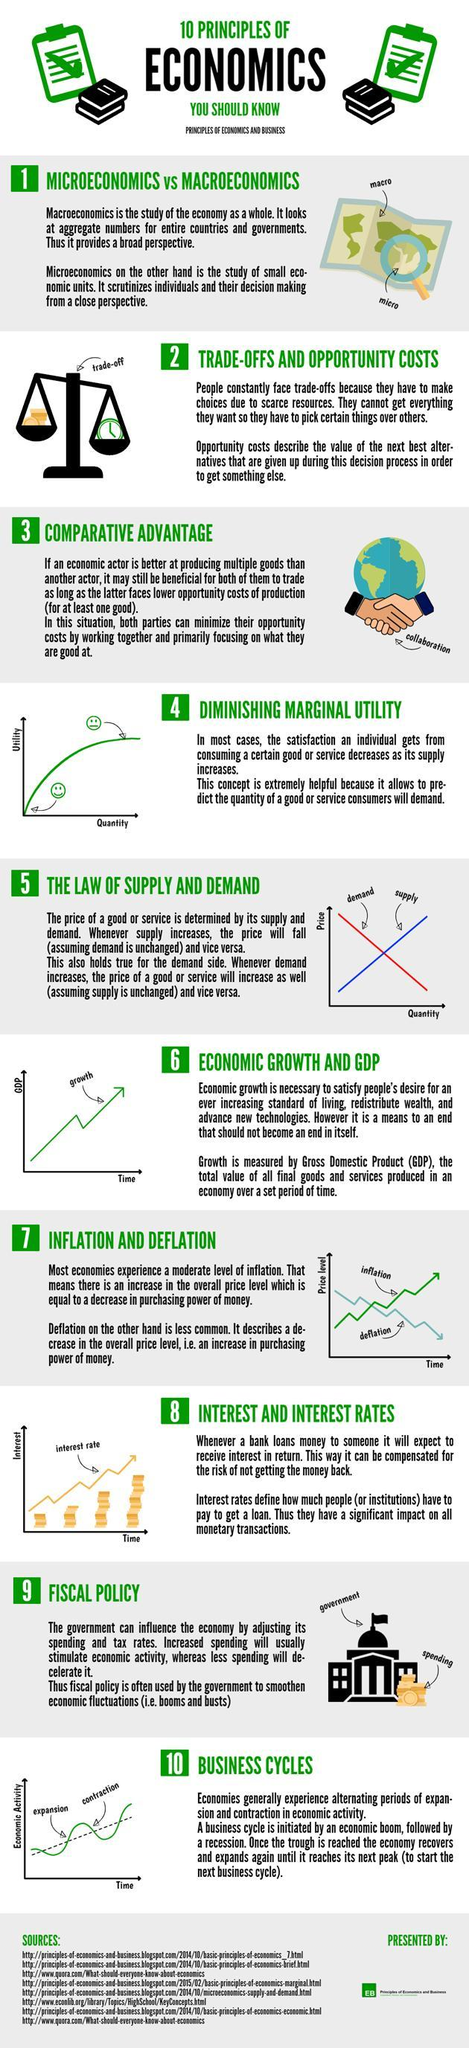What is the colour of the demand line in graph- blue or red?
Answer the question with a short phrase. Red How many sources are listed? 8 Which is more common- inflation or deflation? Inflation What predicts the quantity of a good or service consumers will demand? DIMINISHING MARGINAL UTILITY 